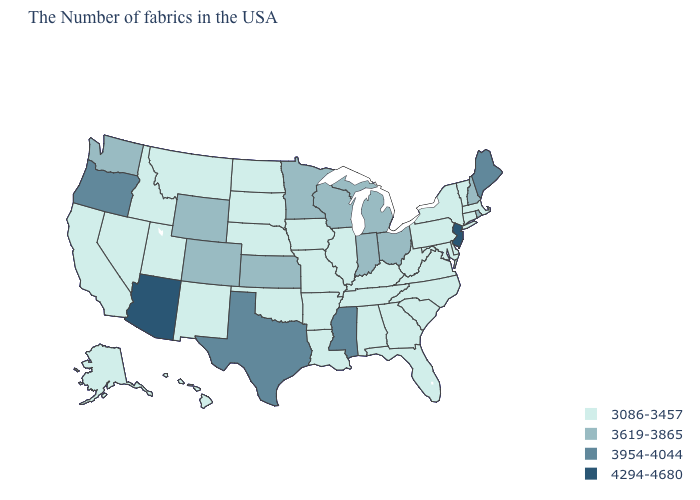Does Tennessee have the same value as Texas?
Answer briefly. No. Is the legend a continuous bar?
Write a very short answer. No. What is the value of New Jersey?
Concise answer only. 4294-4680. What is the highest value in states that border Oregon?
Short answer required. 3619-3865. Does the map have missing data?
Answer briefly. No. What is the value of Missouri?
Keep it brief. 3086-3457. What is the value of Oklahoma?
Short answer required. 3086-3457. Name the states that have a value in the range 4294-4680?
Give a very brief answer. New Jersey, Arizona. How many symbols are there in the legend?
Write a very short answer. 4. Which states have the highest value in the USA?
Short answer required. New Jersey, Arizona. Is the legend a continuous bar?
Be succinct. No. What is the value of Wyoming?
Write a very short answer. 3619-3865. What is the value of Georgia?
Short answer required. 3086-3457. What is the lowest value in the MidWest?
Give a very brief answer. 3086-3457. Name the states that have a value in the range 3086-3457?
Write a very short answer. Massachusetts, Vermont, Connecticut, New York, Delaware, Maryland, Pennsylvania, Virginia, North Carolina, South Carolina, West Virginia, Florida, Georgia, Kentucky, Alabama, Tennessee, Illinois, Louisiana, Missouri, Arkansas, Iowa, Nebraska, Oklahoma, South Dakota, North Dakota, New Mexico, Utah, Montana, Idaho, Nevada, California, Alaska, Hawaii. 